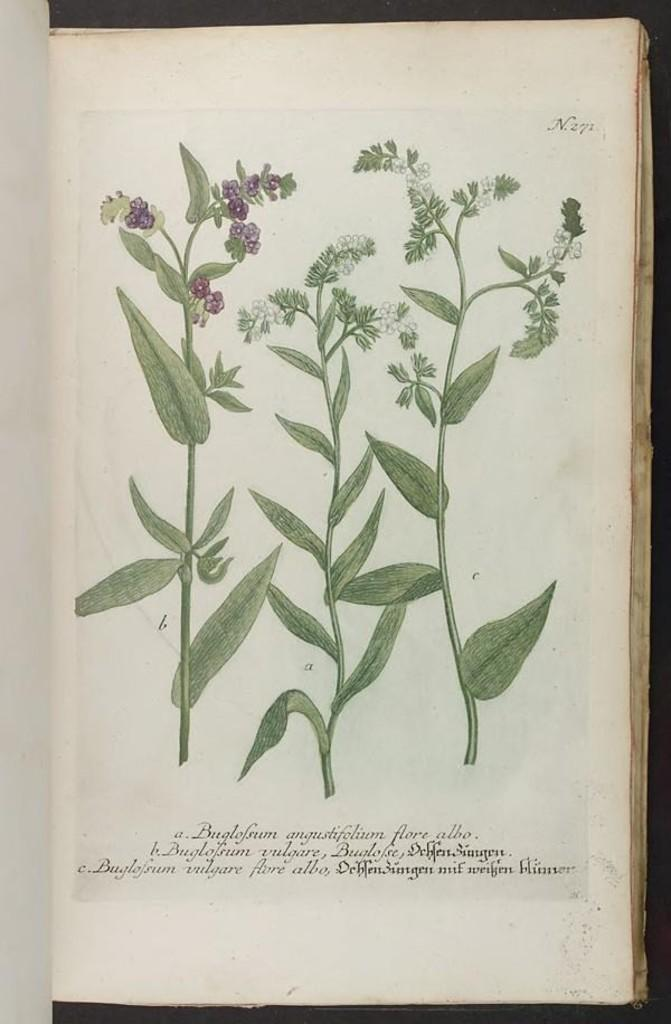What is the main subject in the foreground of the image? There is a book in the foreground of the image. What type of content is featured in the book? The book contains images of plants. Is there any text present in the book? Yes, there is text at the bottom of the book. Can you hear the book crying in the image? There is no sound or crying in the image, as it is a still image of a book. 